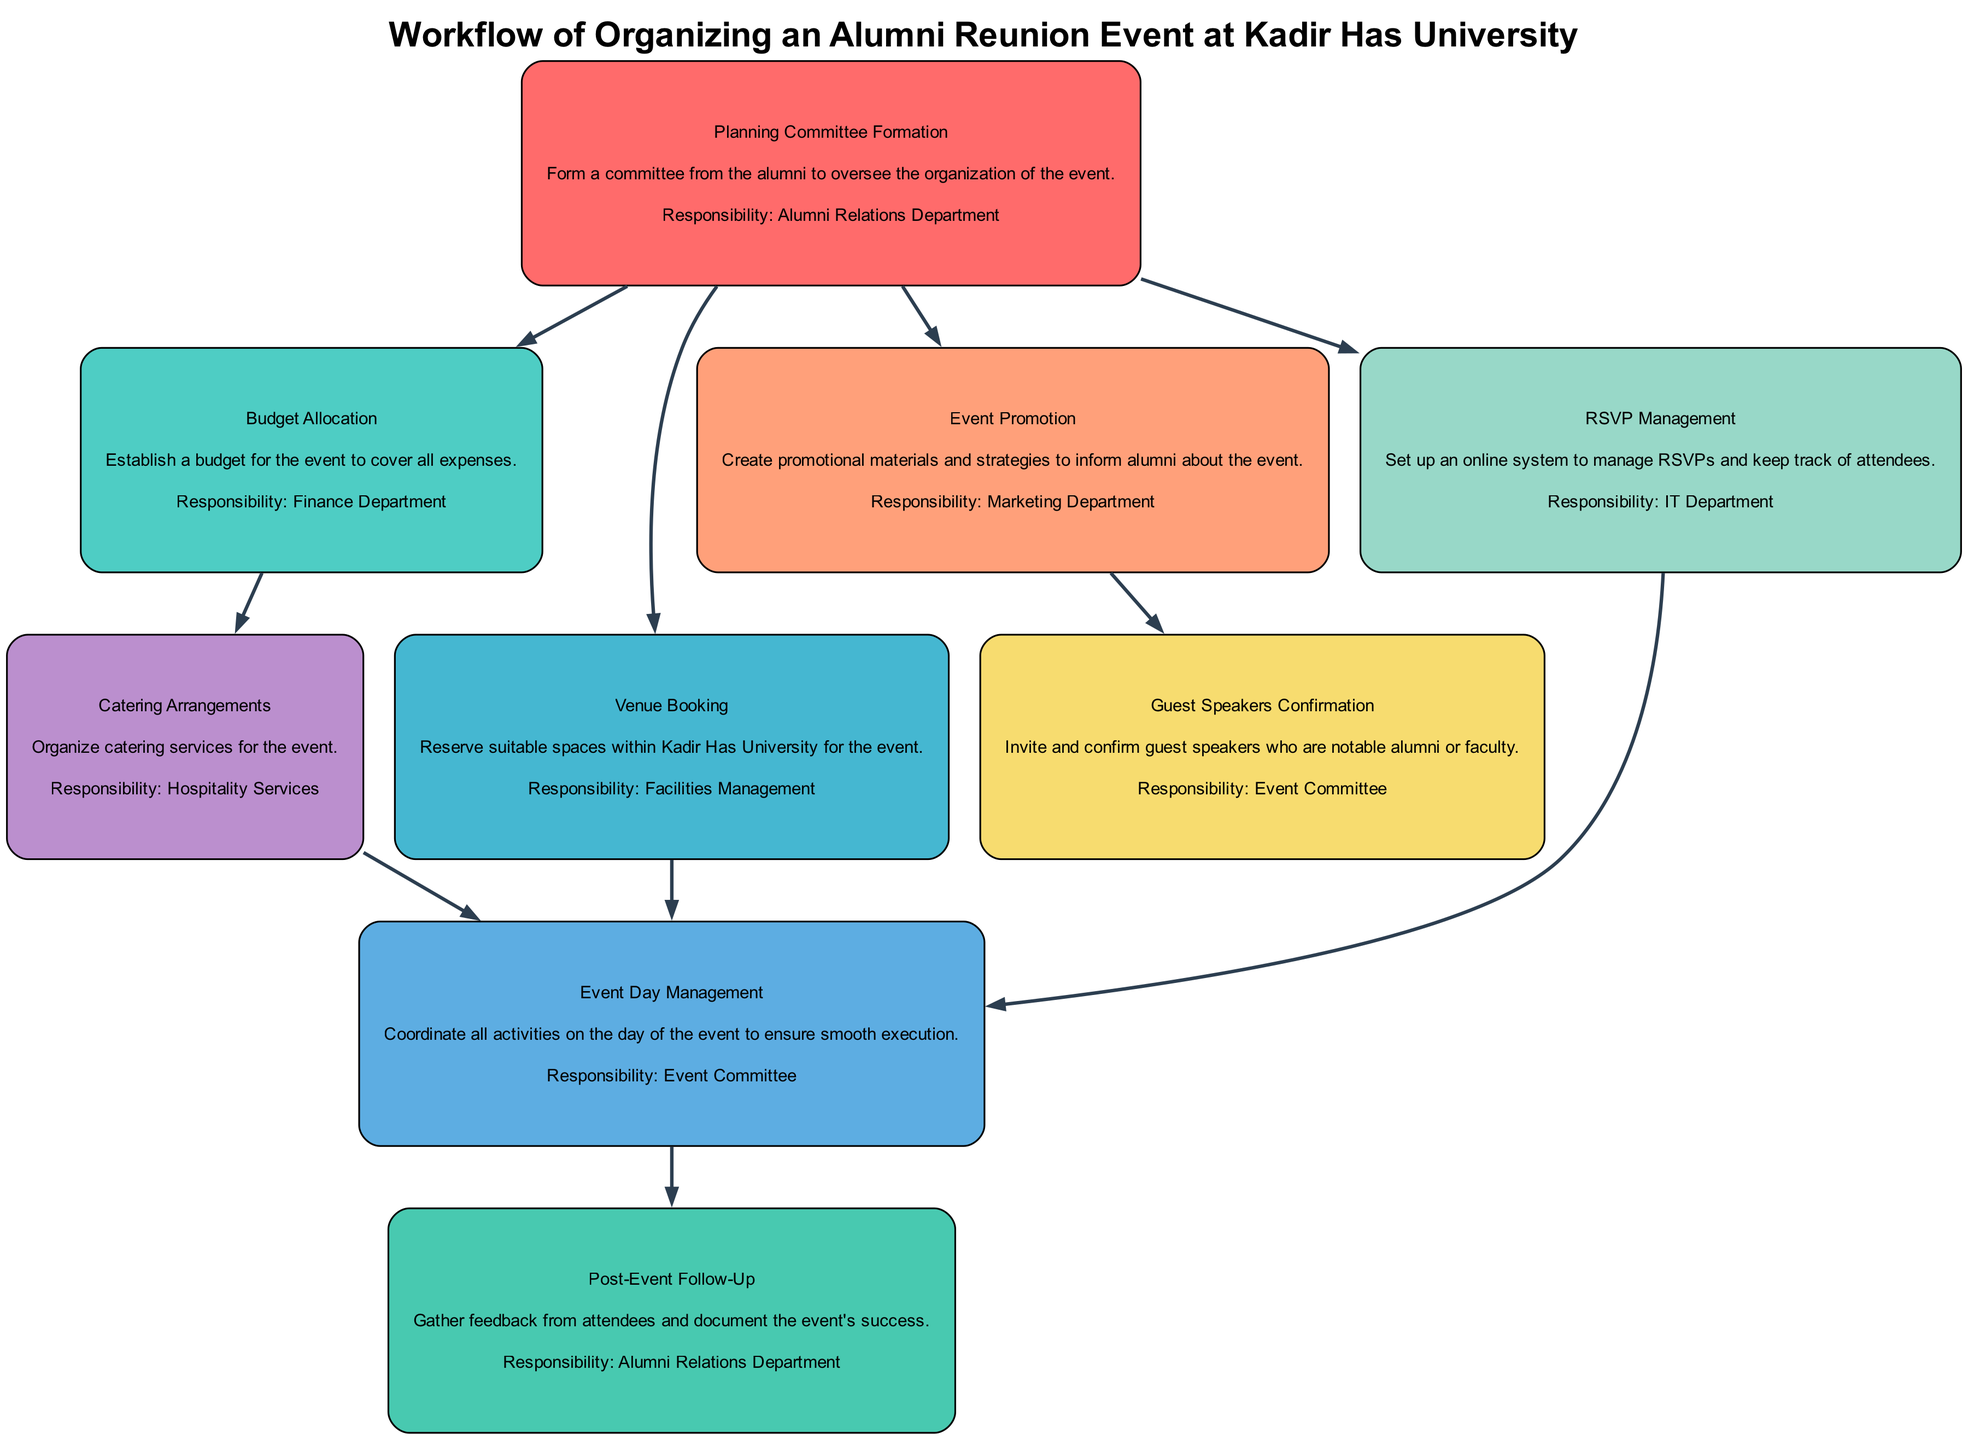What is the first step in the workflow? The diagram illustrates that the initial step is the formation of the Planning Committee, as indicated by the first node labeled "Planning Committee Formation."
Answer: Planning Committee Formation How many departments are involved in planning the reunion? By analyzing the responsibilities listed in the nodes, the departments involved are the Alumni Relations Department, Finance Department, Facilities Management, Marketing Department, IT Department, and Hospitality Services. This totals six departments.
Answer: Six What is the responsibility of the Marketing Department? The diagram specifies that the Marketing Department is responsible for "Event Promotion," which indicates their role in creating promotional materials and strategies for the event.
Answer: Event Promotion Which node leads to the "Event Day Management"? Looking at the edges flowing into the "Event Day Management" node, the relevant connections are from "Venue Booking," "RSVP Management," and "Catering Arrangements," all of which are necessary for event execution on the day.
Answer: Venue Booking, RSVP Management, Catering Arrangements Which department is responsible for the "Post-Event Follow-Up"? Upon examining the nodes, it is clear that the "Post-Event Follow-Up" responsibility falls under the Alumni Relations Department, as indicated in the diagram.
Answer: Alumni Relations Department What activity directly follows the "Event Day Management"? Upon close inspection of the directed edge leading from "Event Day Management," it shows that the next activity is "Post-Event Follow-Up," indicating that the follow-up occurs after managing the event.
Answer: Post-Event Follow-Up How many edges are in the diagram? Counting the edges documented in the diagram reveals that there are ten connections between the nodes, which indicate the workflow progression from one activity to another.
Answer: Ten Which responsibility comes before Budget Allocation in the sequence? The diagram shows that the responsibilities originating from the "Planning Committee Formation" include Budget Allocation, but there are no activities before it, as it is the second step in the sequence.
Answer: Planning Committee Formation 